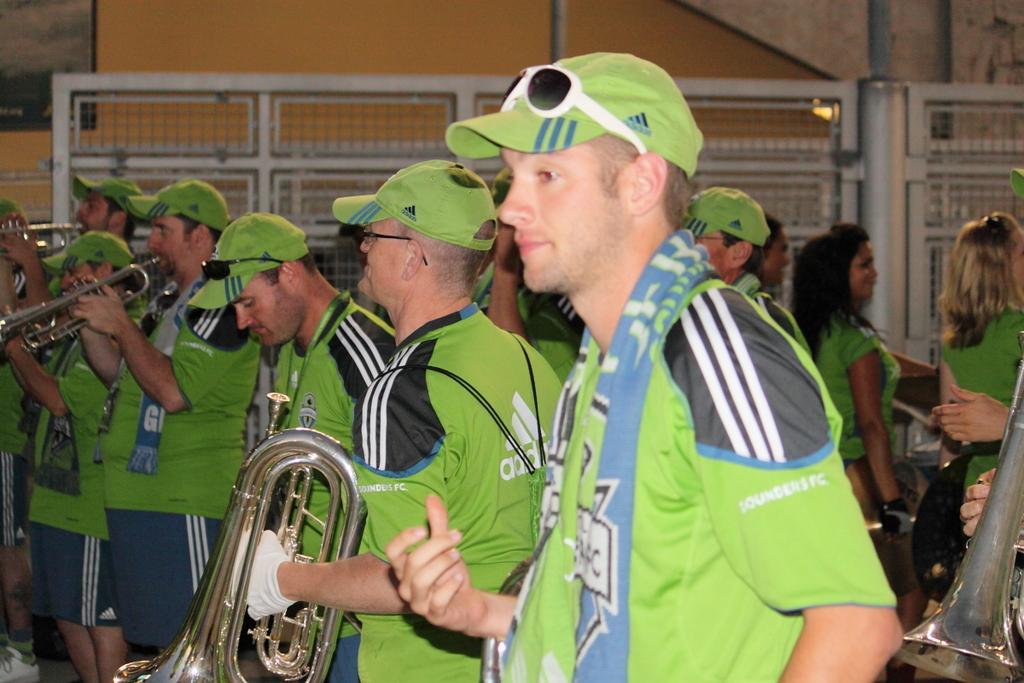Describe this image in one or two sentences. In the image there are men with caps and goggles. They are holding musical instruments and few of them are playing. Behind them there are ladies. In the background there is a fencing with mesh and poles. Behind the fencing there is a wall with a frame. 